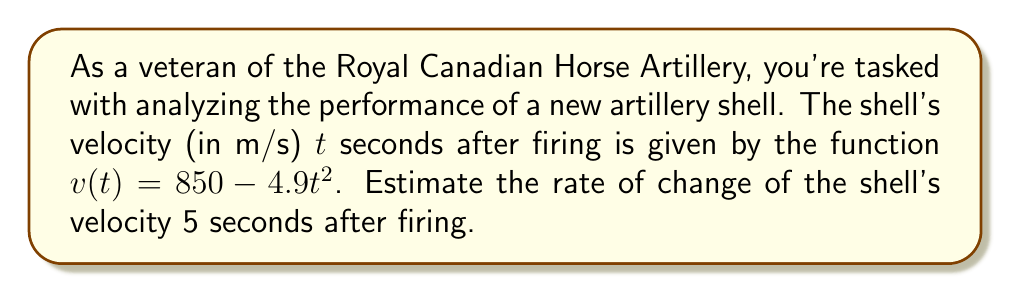Provide a solution to this math problem. To estimate the rate of change of the shell's velocity, we need to find the derivative of the velocity function and evaluate it at t = 5. Let's break this down step-by-step:

1) The velocity function is given as:
   $$v(t) = 850 - 4.9t^2$$

2) To find the rate of change, we need to find $v'(t)$. Using the power rule of differentiation:
   $$v'(t) = 0 - 4.9 \cdot 2t = -9.8t$$

3) This derivative, $v'(t)$, represents the instantaneous rate of change of velocity, which is acceleration.

4) To find the rate of change at t = 5 seconds, we substitute t = 5 into our derivative function:
   $$v'(5) = -9.8 \cdot 5 = -49$$

5) The negative value indicates that the velocity is decreasing, which is expected as the shell slows down due to air resistance and gravity.

6) The units of this rate of change are meters per second per second (m/s²), which is the unit of acceleration.
Answer: The rate of change of the shell's velocity 5 seconds after firing is $-49$ m/s². 